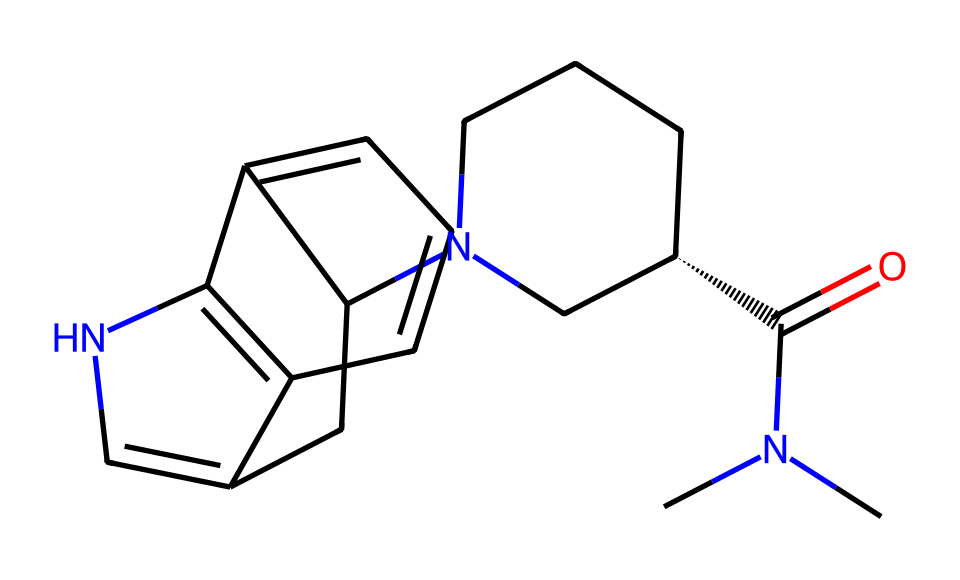how many carbon atoms are present in the structure? To find the number of carbon atoms in the SMILES representation, we count all 'C' characters. In this structure, there are 16 carbon atoms.
Answer: 16 what is the functional group present in this chemical? The functional group is identified by looking for specific atoms and their arrangement. This structure contains an amide group (C(=O)N), which is indicative of the presence of the amide functional group.
Answer: amide how many rings are found in the molecular structure? By examining the structure in the SMILES representation, we recognize there are two distinct ring systems forming from the connected carbon atoms and their cyclic arrangement, resulting in two rings overall.
Answer: 2 what type of drug is represented by this molecule? The chemical structure suggests a psychedelic compound, as it has structural similarities to known psychedelic drugs such as LSD due to the presence of a tryptamine-like framework and cyclic structures.
Answer: psychedelic why might this drug cause hallucinations? The drug's structure includes a complex arrangement that allows it to interact with serotonin receptors in the brain. The rings and nitrogen atoms within the molecule indicate it may fit into these receptors effectively, leading to the alterations in perception typical of hallucinations.
Answer: serotonin interaction 